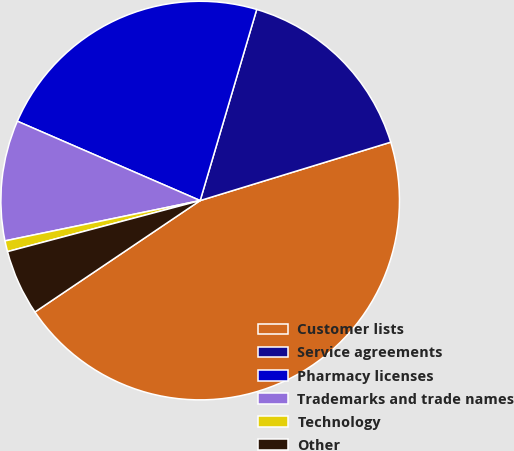Convert chart to OTSL. <chart><loc_0><loc_0><loc_500><loc_500><pie_chart><fcel>Customer lists<fcel>Service agreements<fcel>Pharmacy licenses<fcel>Trademarks and trade names<fcel>Technology<fcel>Other<nl><fcel>45.29%<fcel>15.69%<fcel>23.06%<fcel>9.76%<fcel>0.88%<fcel>5.32%<nl></chart> 